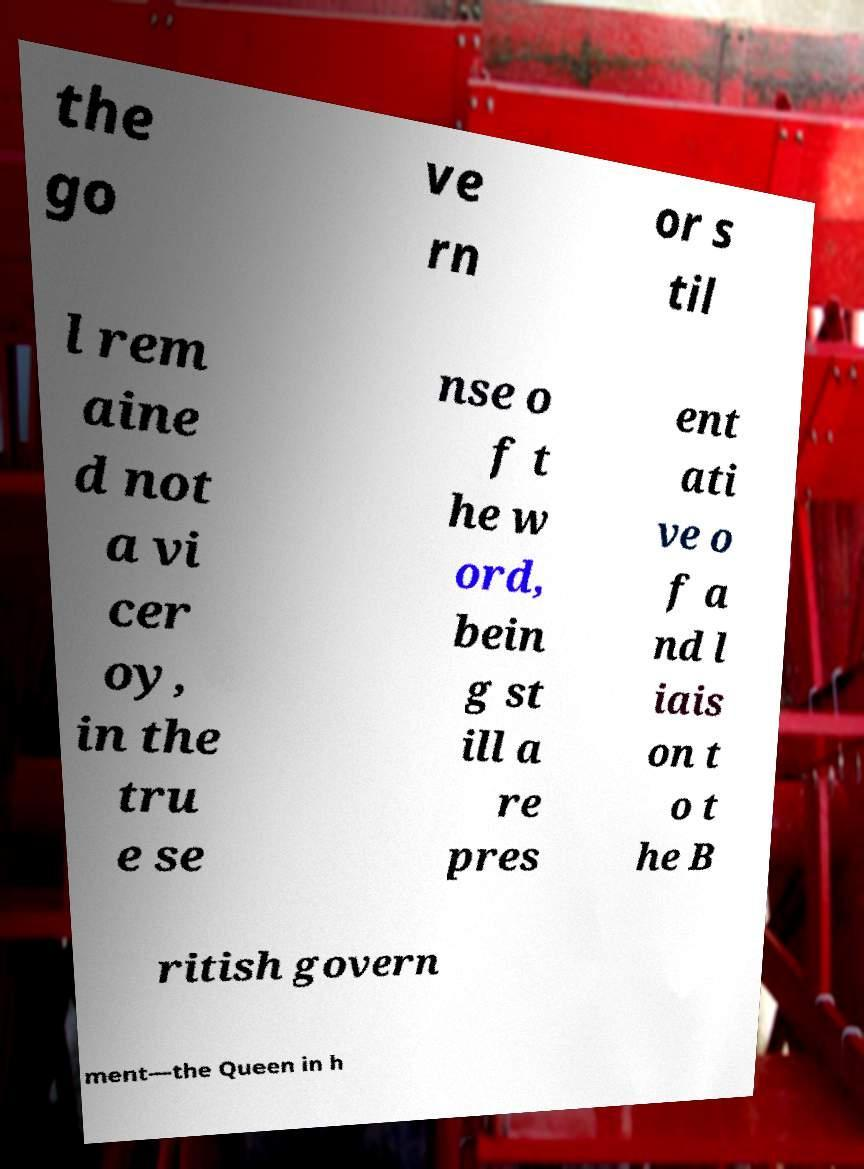Could you assist in decoding the text presented in this image and type it out clearly? the go ve rn or s til l rem aine d not a vi cer oy, in the tru e se nse o f t he w ord, bein g st ill a re pres ent ati ve o f a nd l iais on t o t he B ritish govern ment—the Queen in h 